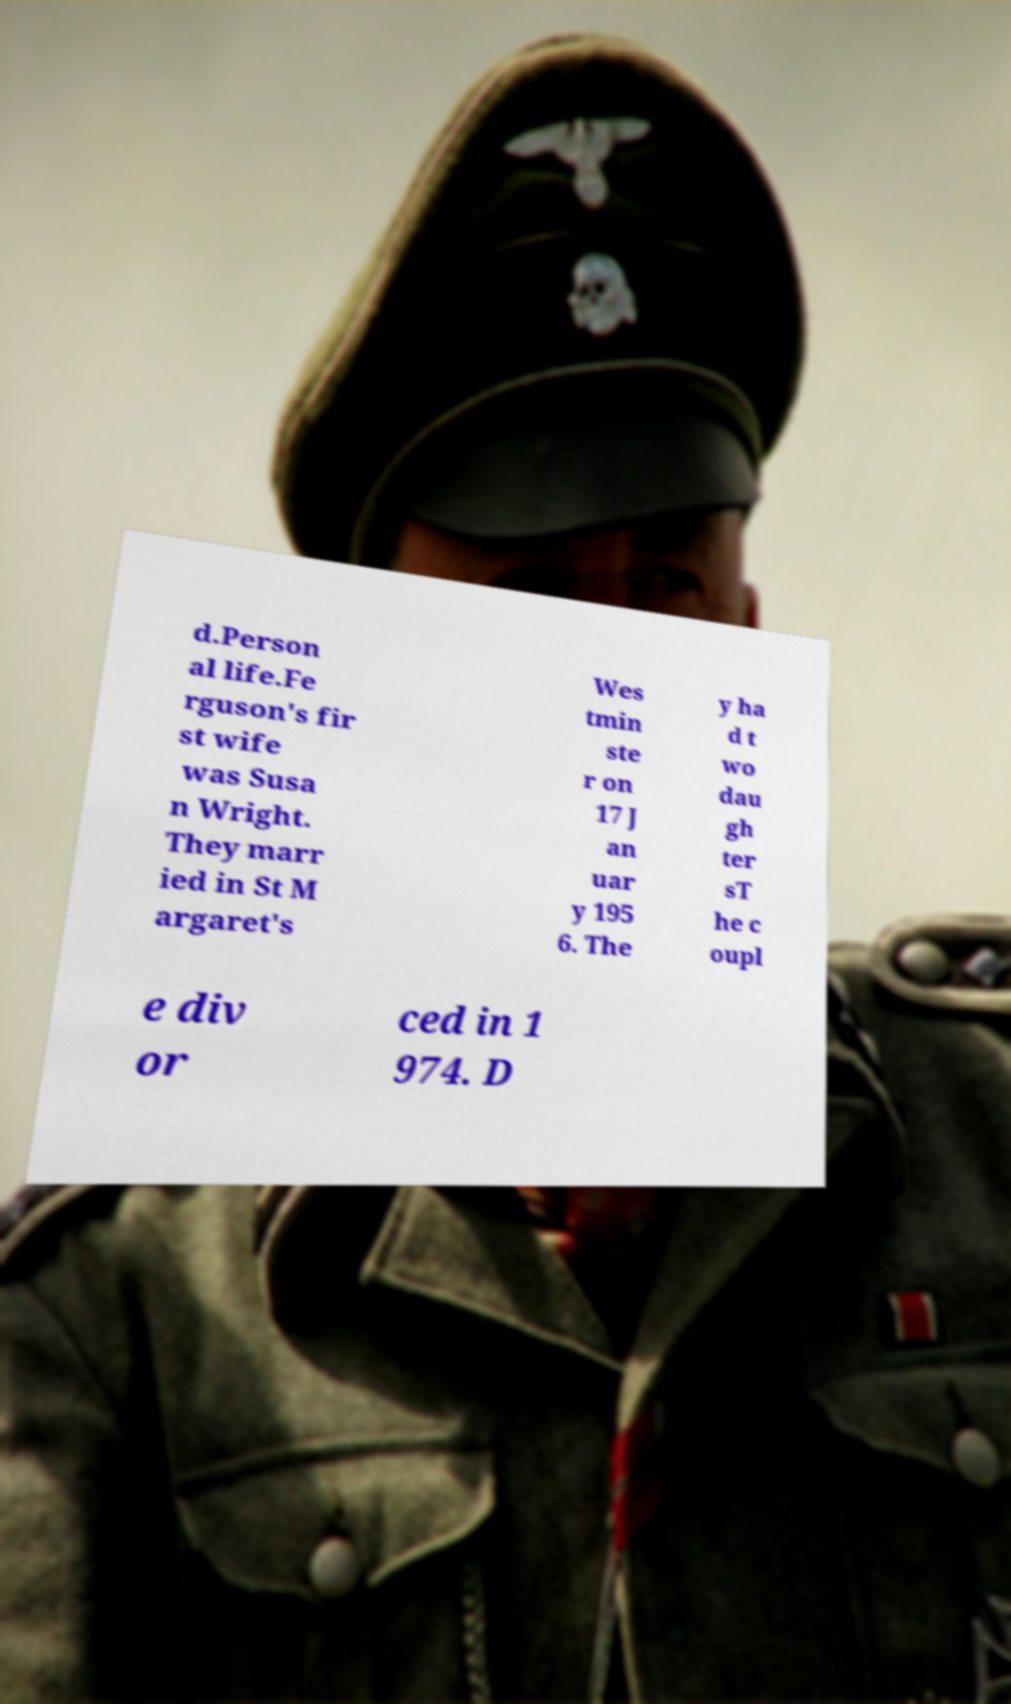Could you assist in decoding the text presented in this image and type it out clearly? d.Person al life.Fe rguson's fir st wife was Susa n Wright. They marr ied in St M argaret's Wes tmin ste r on 17 J an uar y 195 6. The y ha d t wo dau gh ter sT he c oupl e div or ced in 1 974. D 